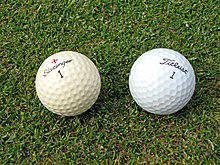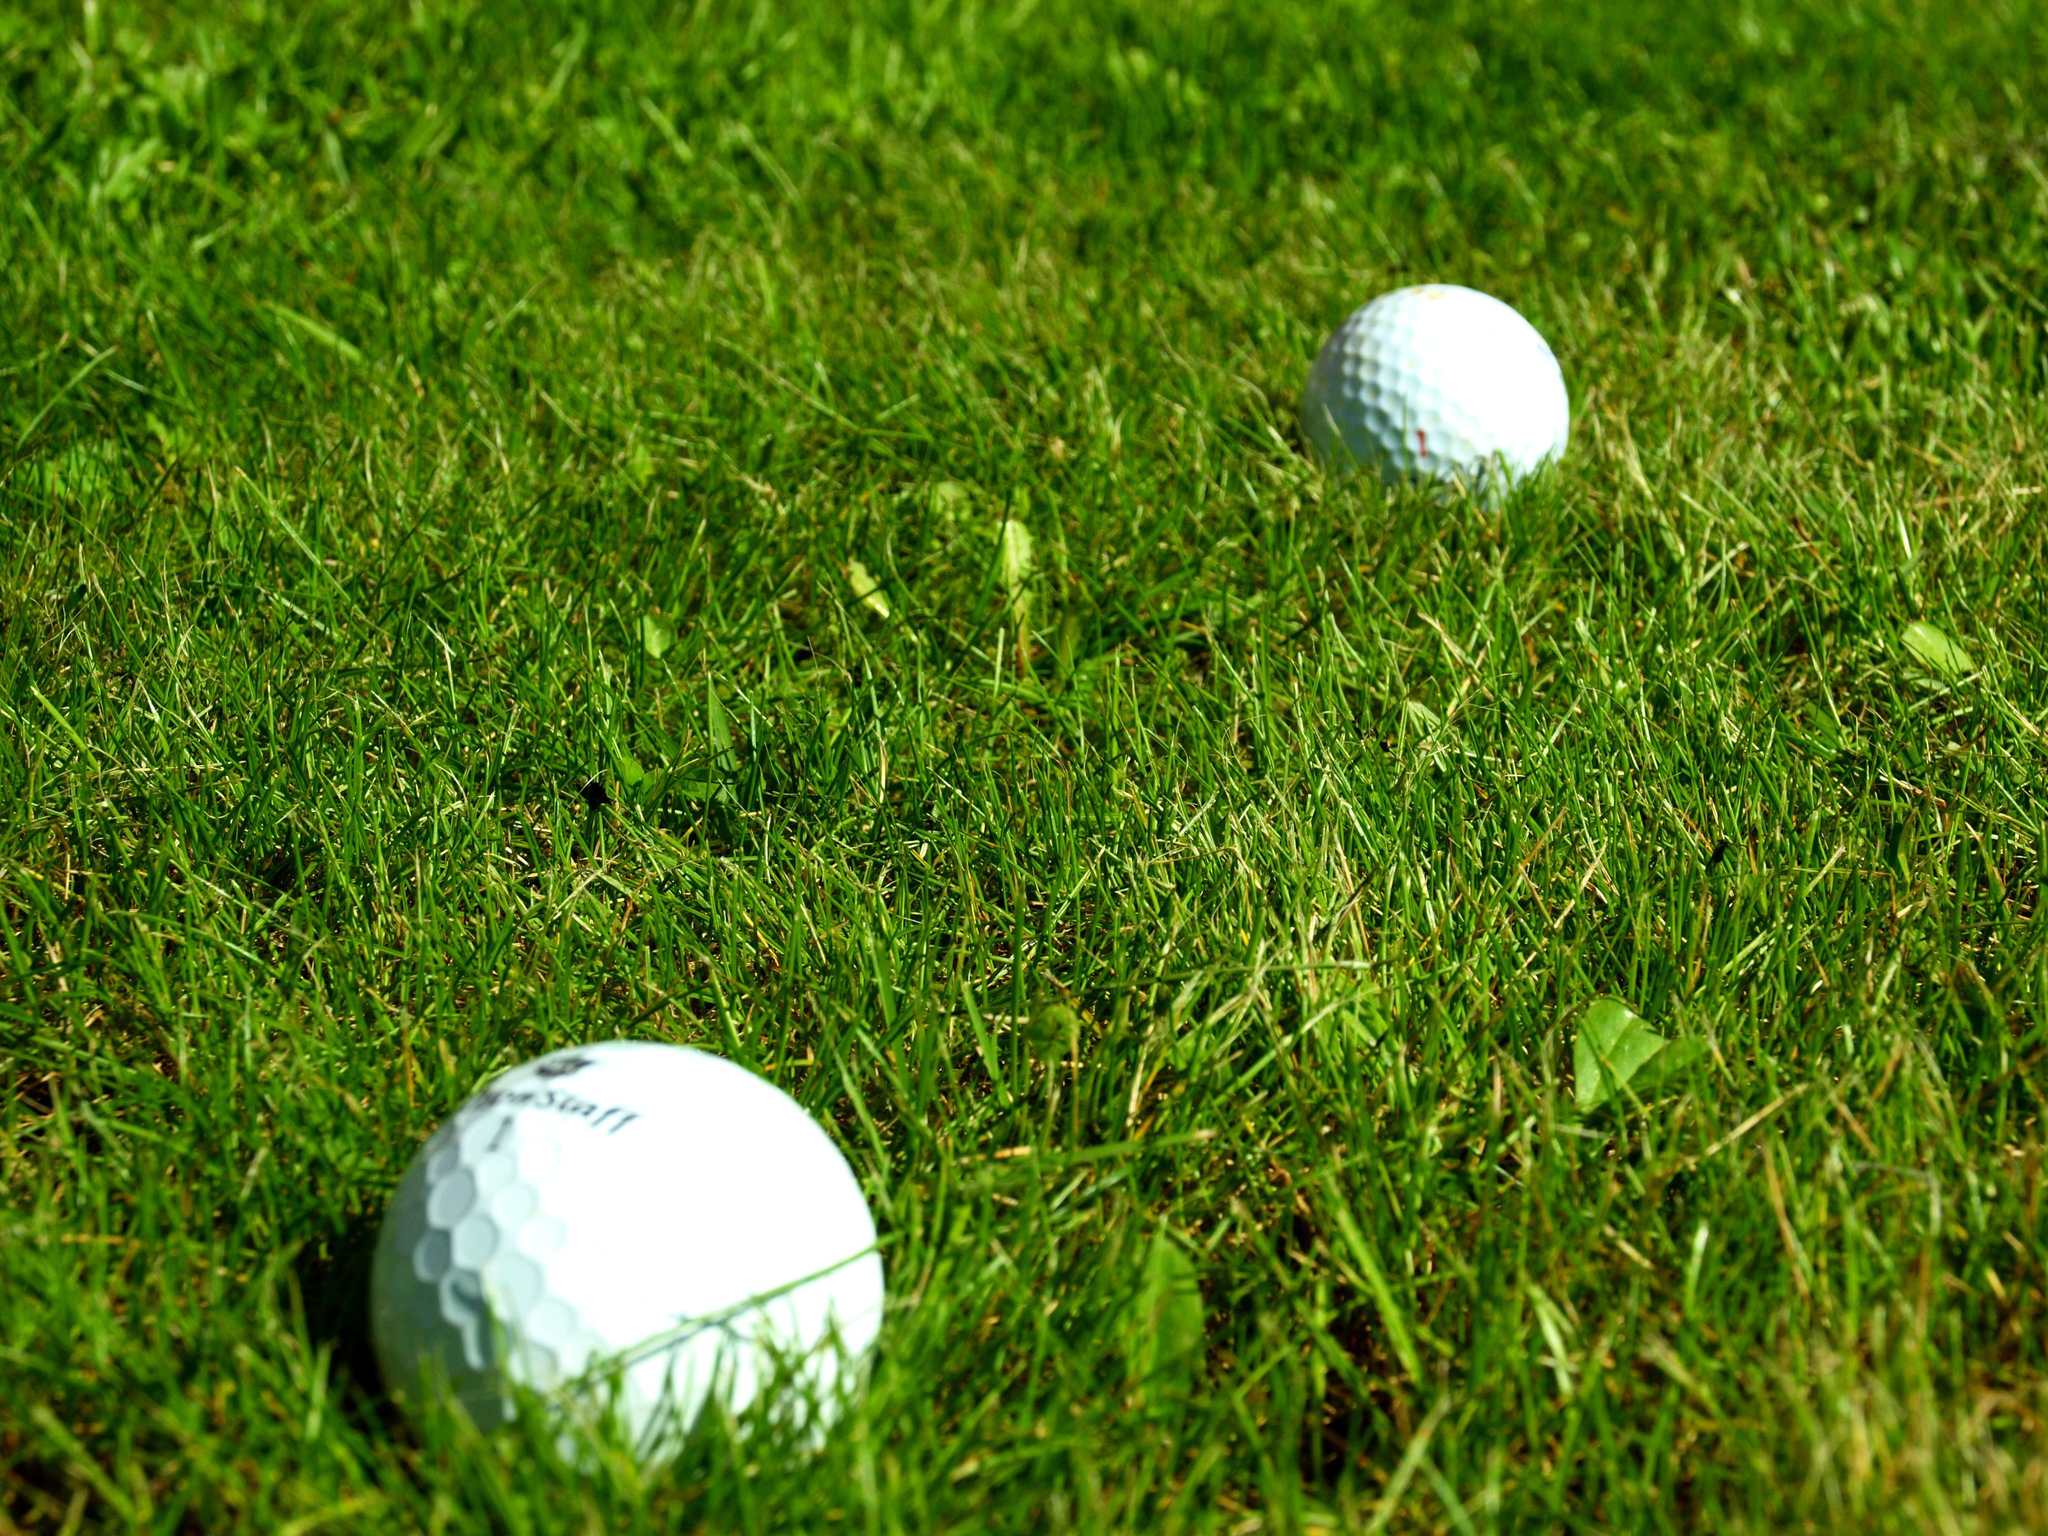The first image is the image on the left, the second image is the image on the right. Assess this claim about the two images: "In one of the images there are at least two golf balls positioned near a hole with a golf flagpole inserted in it.". Correct or not? Answer yes or no. No. The first image is the image on the left, the second image is the image on the right. Examine the images to the left and right. Is the description "An image shows multiple golf balls near a hole with a pole in it." accurate? Answer yes or no. No. 